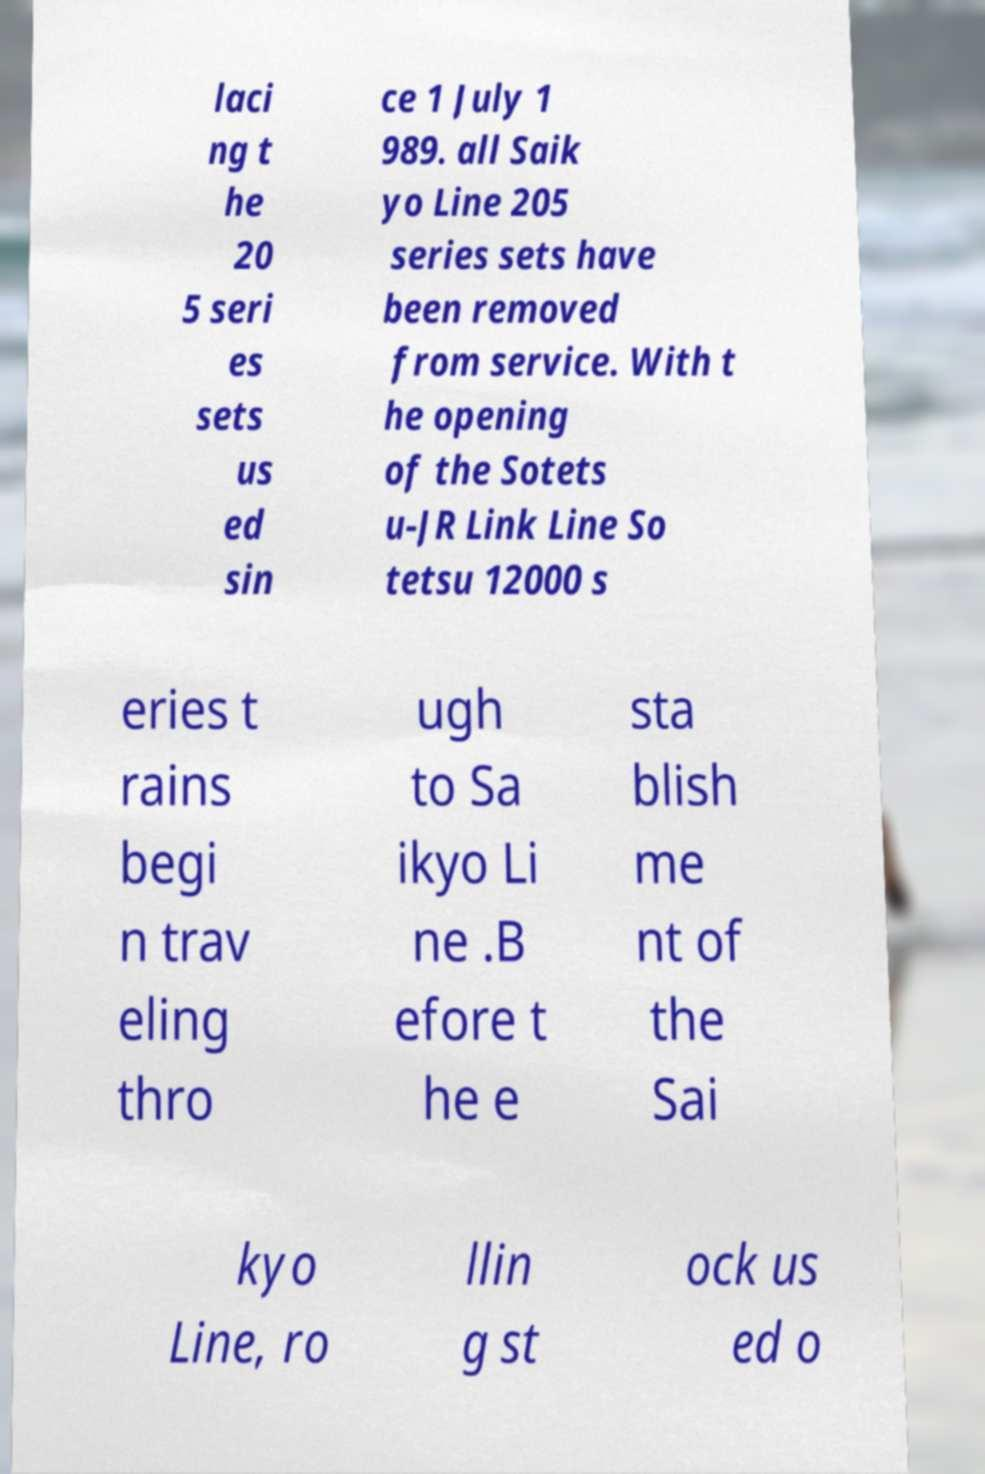Please identify and transcribe the text found in this image. laci ng t he 20 5 seri es sets us ed sin ce 1 July 1 989. all Saik yo Line 205 series sets have been removed from service. With t he opening of the Sotets u-JR Link Line So tetsu 12000 s eries t rains begi n trav eling thro ugh to Sa ikyo Li ne .B efore t he e sta blish me nt of the Sai kyo Line, ro llin g st ock us ed o 